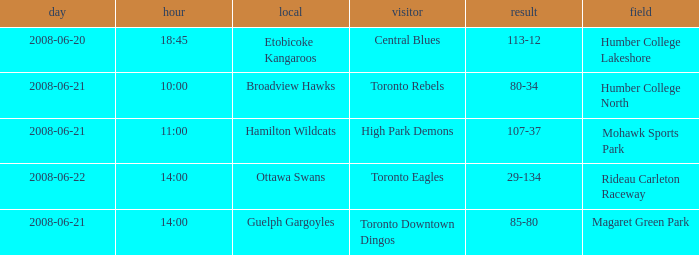What is the Time with a Score that is 80-34? 10:00. 